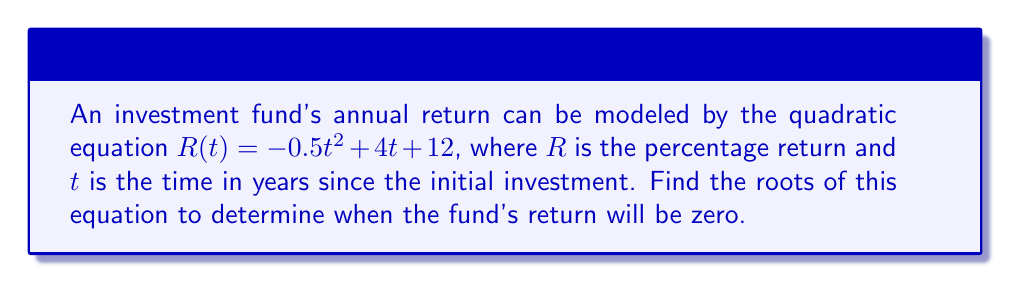Provide a solution to this math problem. To find the roots of the quadratic equation, we need to solve $R(t) = 0$:

1) Set the equation equal to zero:
   $-0.5t^2 + 4t + 12 = 0$

2) Multiply all terms by -2 to simplify the leading coefficient:
   $t^2 - 8t - 24 = 0$

3) Use the quadratic formula: $t = \frac{-b \pm \sqrt{b^2 - 4ac}}{2a}$
   Where $a = 1$, $b = -8$, and $c = -24$

4) Substitute these values into the quadratic formula:
   $t = \frac{8 \pm \sqrt{(-8)^2 - 4(1)(-24)}}{2(1)}$

5) Simplify under the square root:
   $t = \frac{8 \pm \sqrt{64 + 96}}{2} = \frac{8 \pm \sqrt{160}}{2}$

6) Simplify the square root:
   $t = \frac{8 \pm 4\sqrt{10}}{2}$

7) Separate the two solutions:
   $t_1 = \frac{8 + 4\sqrt{10}}{2} = 4 + 2\sqrt{10}$
   $t_2 = \frac{8 - 4\sqrt{10}}{2} = 4 - 2\sqrt{10}$

Therefore, the roots of the equation are $4 + 2\sqrt{10}$ and $4 - 2\sqrt{10}$ years.
Answer: $t_1 = 4 + 2\sqrt{10}$, $t_2 = 4 - 2\sqrt{10}$ years 